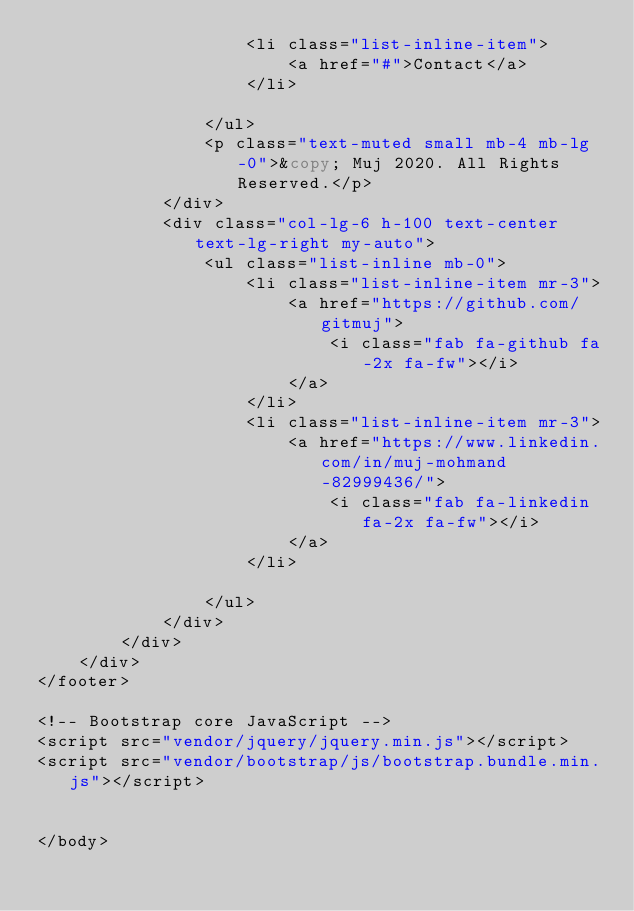<code> <loc_0><loc_0><loc_500><loc_500><_PHP_>                    <li class="list-inline-item">
                        <a href="#">Contact</a>
                    </li>

                </ul>
                <p class="text-muted small mb-4 mb-lg-0">&copy; Muj 2020. All Rights Reserved.</p>
            </div>
            <div class="col-lg-6 h-100 text-center text-lg-right my-auto">
                <ul class="list-inline mb-0">
                    <li class="list-inline-item mr-3">
                        <a href="https://github.com/gitmuj">
                            <i class="fab fa-github fa-2x fa-fw"></i>
                        </a>
                    </li>
                    <li class="list-inline-item mr-3">
                        <a href="https://www.linkedin.com/in/muj-mohmand-82999436/">
                            <i class="fab fa-linkedin fa-2x fa-fw"></i>
                        </a>
                    </li>

                </ul>
            </div>
        </div>
    </div>
</footer>

<!-- Bootstrap core JavaScript -->
<script src="vendor/jquery/jquery.min.js"></script>
<script src="vendor/bootstrap/js/bootstrap.bundle.min.js"></script>


</body></code> 